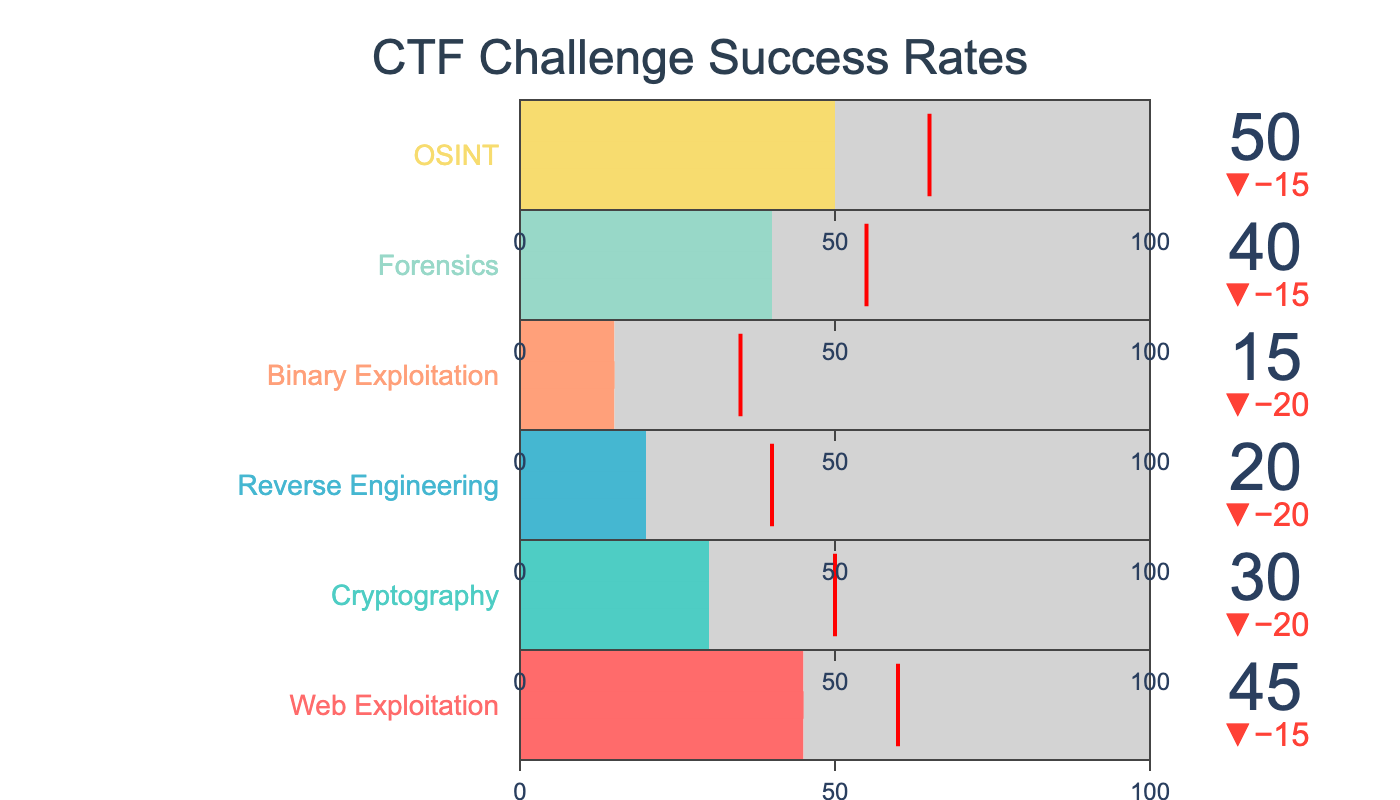What's the highest success rate among the categories? The categories and their respective success rates (Actual) are provided. The highest value among them needs to be identified. The rates are: Web Exploitation - 45, Cryptography - 30, Reverse Engineering - 20, Binary Exploitation - 15, Forensics - 40, OSINT - 50. The highest value is for OSINT at 50.
Answer: OSINT at 50 What percentage of the target has been achieved for Cryptography? To find the percentage of the target achieved for Cryptography, divide the actual success rate by the target rate and multiply by 100. For Cryptography, the actual is 30, and the target is 50. Calculation: (30 / 50) * 100 = 60%.
Answer: 60% Which category needs the least improvement to meet its target? For each category, subtract the actual success rate from the target rate to find the improvement needed. The improvements needed are: Web Exploitation - 15, Cryptography - 20, Reverse Engineering - 20, Binary Exploitation - 20, Forensics - 15, OSINT - 15. The category needing the least improvement is Web Exploitation, Forensics, and OSINT, all needing 15 units.
Answer: Web Exploitation, Forensics, OSINT How does the actual success rate for Reverse Engineering compare to Binary Exploitation? Compare the actual success rates for both categories. Reverse Engineering (20) is higher than Binary Exploitation (15).
Answer: Reverse Engineering is higher What is the average success rate across all categories? Sum the actual success rates and divide by the number of categories. The rates are: 45, 30, 20, 15, 40, 50. Calculation: (45 + 30 + 20 + 15 + 40 + 50) / 6 = 33.33.
Answer: 33.33 Which category has the lowest success rate? Look at the actual success rates and find the lowest value. The rates are: 45, 30, 20, 15, 40, 50. The lowest value is 15, which is for Binary Exploitation.
Answer: Binary Exploitation at 15 If you sum up the targets, which category constitutes the largest portion of this total? Find the sum of the target values and determine the proportion each category contributes. The targets are: 60, 50, 40, 35, 55, 65. Total sum = 305. The largest target is 65 (OSINT). Calculation: (65 / 305) * 100 ≈ 21.31%.
Answer: OSINT What is the median target value? To find the median, order the target values and find the middle value. Ordered values: 35, 40, 50, 55, 60, 65. Median is between 50 and 55, i.e., (50 + 55) / 2 = 52.5.
Answer: 52.5 Compare the delta between actual and target values for Forensics and OSINT. Which has a larger discrepancy? The delta for each category is the difference between the actual and target values. For Forensics, it's 55 - 40 = 15. For OSINT, it's 65 - 50 = 15. Both categories have the same delta value of 15.
Answer: Both have the same delta of 15 